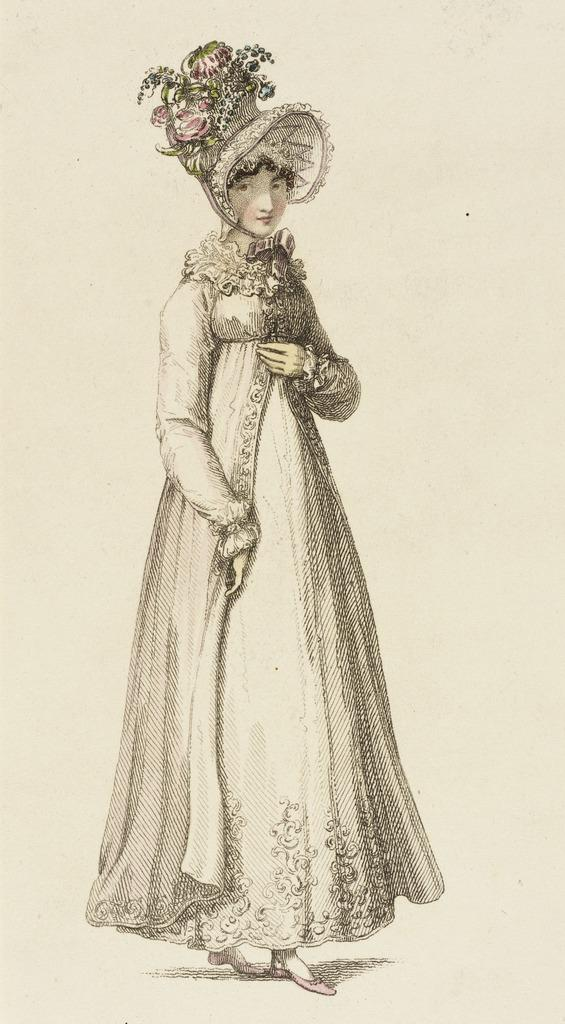What is depicted in the image? There is a sketch of a lady in the image. What is the lady in the sketch wearing? The lady in the sketch is wearing a costume. What is the medium of the sketch? The sketch is on a paper. How many eggs are present in the image? There are no eggs present in the image; it features a sketch of a lady. Who is the manager of the store in the image? There is no store or manager present in the image; it features a sketch of a lady. 